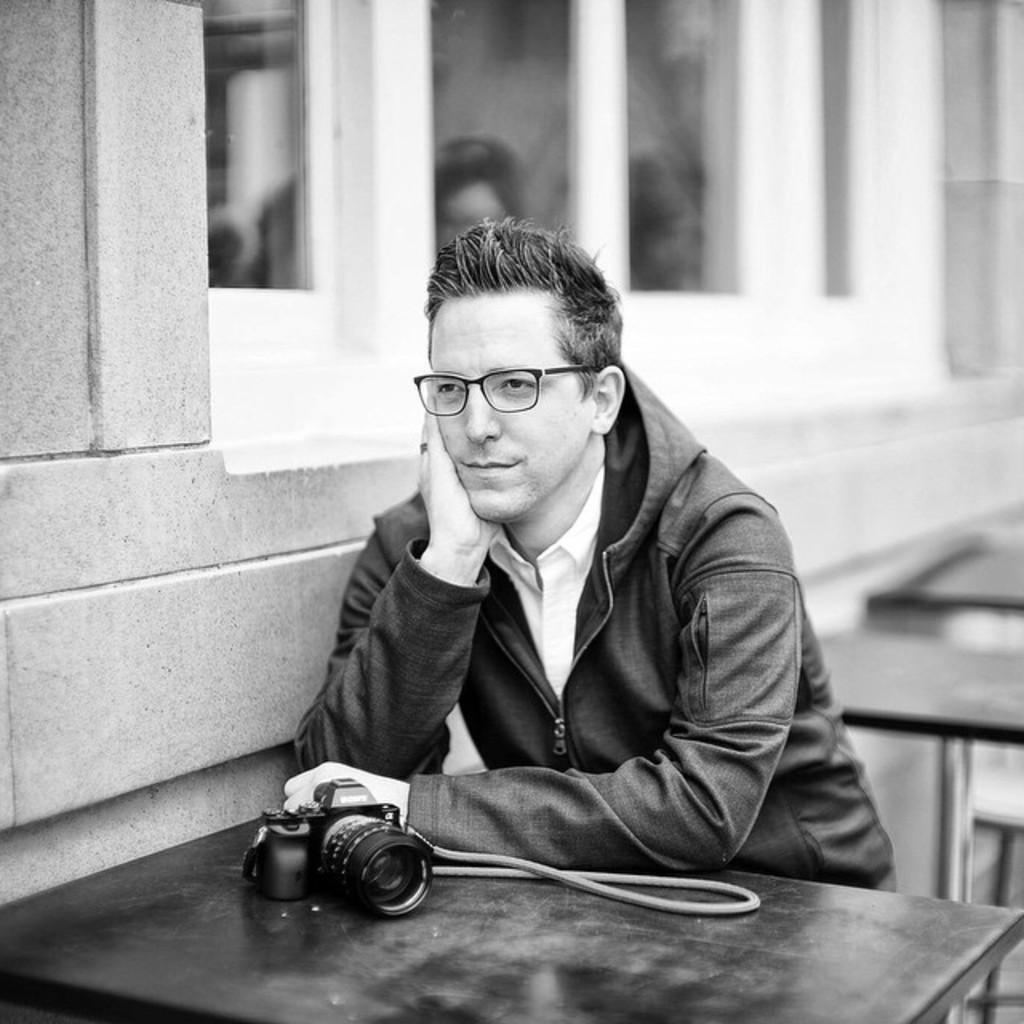What is the color scheme of the image? The image is black and white. What is the person in the image doing? There is a person sitting in the image. What type of furniture can be seen in the image? There are tables in the image. What object is used for capturing images in the image? There is a camera in the image. What is behind the person in the image? There is a wall behind the person. What architectural feature is present in the image that allows natural light to enter? There is a window in the image. What type of stem can be seen growing from the person's head in the image? There is no stem growing from the person's head in the image; it is a black and white photograph of a person sitting. 